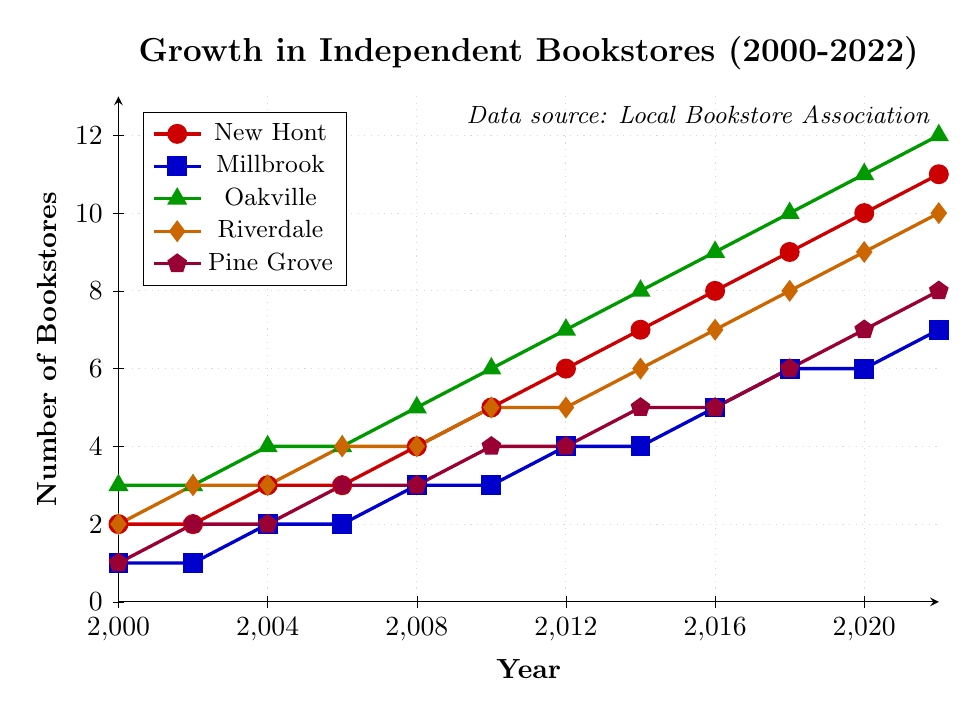What is the number of independent bookstores in New Hont in 2022? The point where the red line intersects with the vertical line at 2022 gives the number of bookstores in New Hont, which is 11.
Answer: 11 Which area had the most significant growth in the number of independent bookstores from 2000 to 2022? To determine the most significant growth, calculate the difference between the values in 2000 and 2022 for each area. New Hont increased from 2 to 11 (growth of 9), Millbrook from 1 to 7 (growth of 6), Oakville from 3 to 12 (growth of 9), Riverdale from 2 to 10 (growth of 8), and Pine Grove from 1 to 8 (growth of 7). The areas with the highest growth are New Hont and Oakville, both with a growth of 9.
Answer: New Hont and Oakville Between which years did Millbrook see the most significant increase in the number of bookstores? To find the years with the most significant increase, compare the number of bookstores between consecutive years for Millbrook. The most considerable increase (by 1 bookstore) occurred between 2002-2004, 2008-2010, and 2016-2018.
Answer: 2002-2004, 2008-2010, and 2016-2018 What was the combined number of independent bookstores in Oakville and Pine Grove in the year 2016? First, locate the values for Oakville and Pine Grove in 2016, which are 9 and 5, respectively. Then, sum these values: 9 + 5 = 14.
Answer: 14 How many years did it take for Riverdale to double the number of independent bookstores from its initial count in 2000? Riverdale had 2 bookstores in 2000. To find when it doubled to 4, check when the orange line reaches 4. This happens in 2006. The difference is 2006 - 2000 = 6 years.
Answer: 6 years Which area had the least variation in the number of independent bookstores from 2000 to 2022? Analyze the trends of all areas. Millbrook shows the least variation since it increased steadily and gradually from 1 to 7, compared to other areas which show more fluctuation and steeper increases or decreases.
Answer: Millbrook In which year did New Hont first surpass Riverdale in the number of independent bookstores? New Hont had consistently fewer independent bookstores than Riverdale until they both had 4 in 2008. In 2010, New Hont had 5 while Riverdale had 4, so New Hont surpassed Riverdale in 2010.
Answer: 2010 From 2000 to 2022, calculate the average annual increase in the number of independent bookstores for Oakville. The number of bookstores in Oakville in 2000 was 3, and in 2022 it was 12. The increase over 22 years is 12 - 3 = 9. The average annual increase = 9 / 22 ≈ 0.41.
Answer: ≈ 0.41 What is the difference in the number of independent bookstores between New Hont and Pine Grove in 2022? The number of bookstores in New Hont in 2022 is 11, and in Pine Grove, it is 8. The difference is 11 - 8 = 3.
Answer: 3 